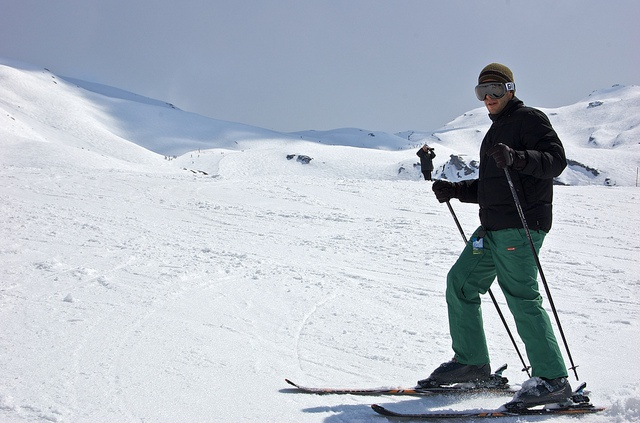Describe the objects in this image and their specific colors. I can see people in gray, black, teal, and purple tones, skis in gray, black, and darkgray tones, and people in gray, black, darkgray, and lightgray tones in this image. 